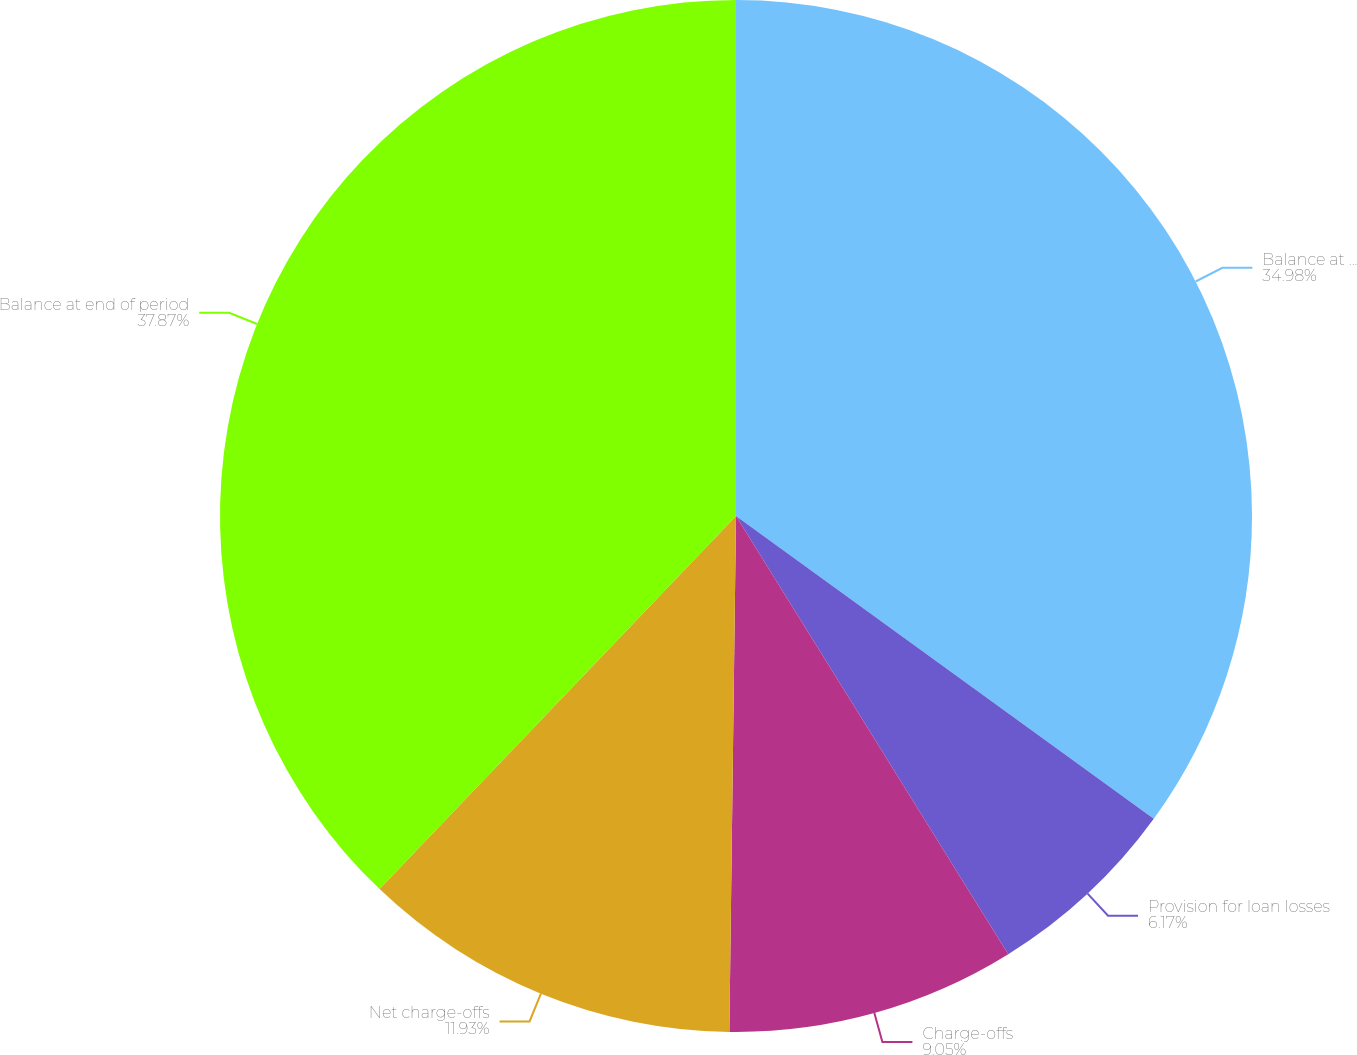Convert chart. <chart><loc_0><loc_0><loc_500><loc_500><pie_chart><fcel>Balance at beginning of period<fcel>Provision for loan losses<fcel>Charge-offs<fcel>Net charge-offs<fcel>Balance at end of period<nl><fcel>34.98%<fcel>6.17%<fcel>9.05%<fcel>11.93%<fcel>37.86%<nl></chart> 